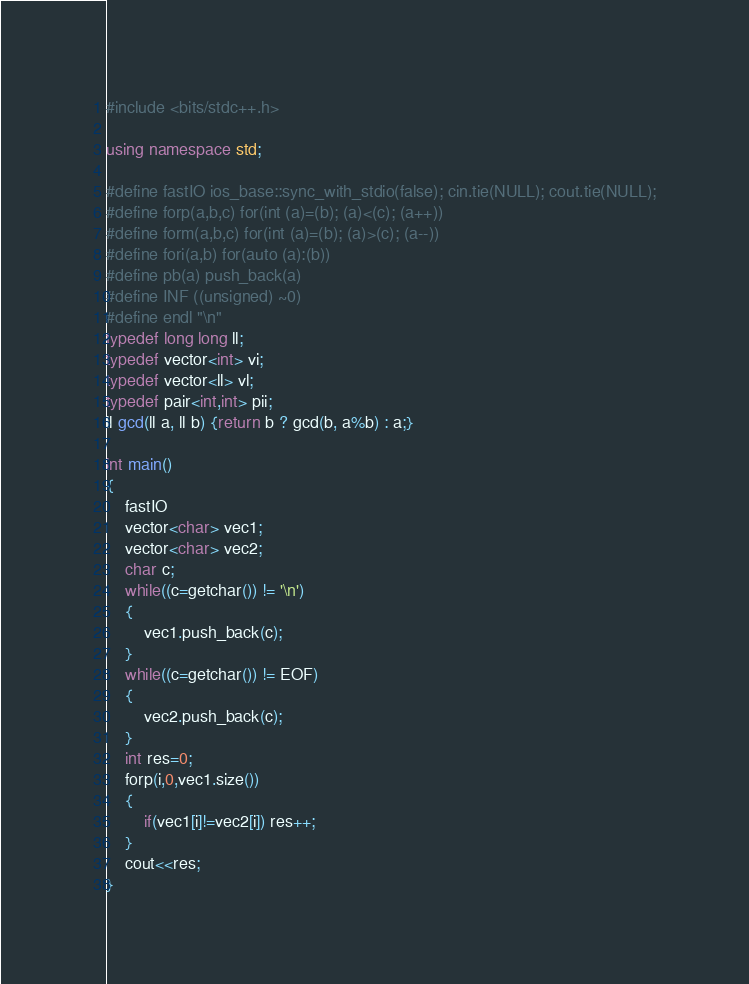<code> <loc_0><loc_0><loc_500><loc_500><_C++_>#include <bits/stdc++.h>
 
using namespace std;
 
#define fastIO ios_base::sync_with_stdio(false); cin.tie(NULL); cout.tie(NULL);
#define forp(a,b,c) for(int (a)=(b); (a)<(c); (a++))
#define form(a,b,c) for(int (a)=(b); (a)>(c); (a--))
#define fori(a,b) for(auto (a):(b))
#define pb(a) push_back(a)
#define INF ((unsigned) ~0)
#define endl "\n"
typedef long long ll;
typedef vector<int> vi;
typedef vector<ll> vl;
typedef pair<int,int> pii;
ll gcd(ll a, ll b) {return b ? gcd(b, a%b) : a;}
 
int main()
{
    fastIO
    vector<char> vec1;
    vector<char> vec2;
    char c;
    while((c=getchar()) != '\n')
    {
        vec1.push_back(c);
    }
    while((c=getchar()) != EOF)
    {
        vec2.push_back(c);
    }
    int res=0;
    forp(i,0,vec1.size())
    {
        if(vec1[i]!=vec2[i]) res++;
    }
    cout<<res;
}</code> 